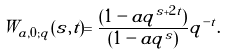Convert formula to latex. <formula><loc_0><loc_0><loc_500><loc_500>W _ { a , 0 ; q } ( s , t ) = \frac { ( 1 - a q ^ { s + 2 t } ) } { ( 1 - a q ^ { s } ) } q ^ { - t } .</formula> 